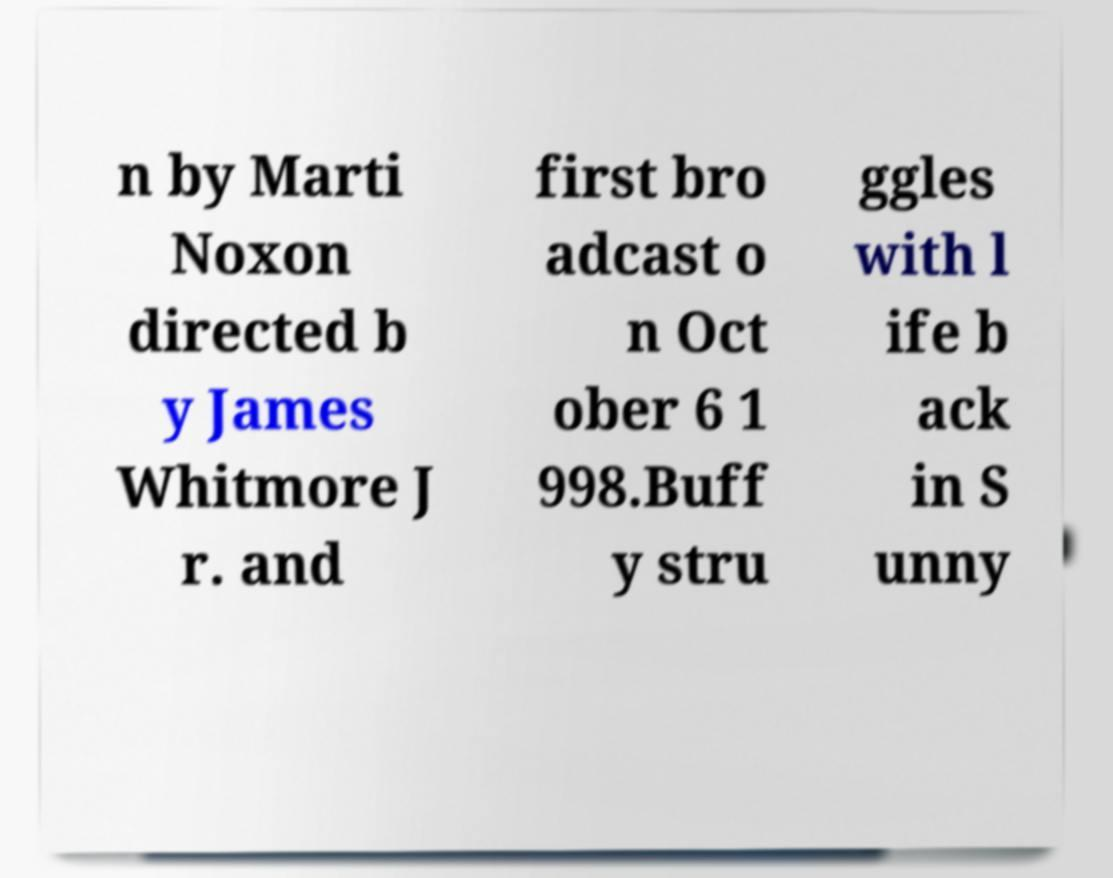Can you accurately transcribe the text from the provided image for me? n by Marti Noxon directed b y James Whitmore J r. and first bro adcast o n Oct ober 6 1 998.Buff y stru ggles with l ife b ack in S unny 